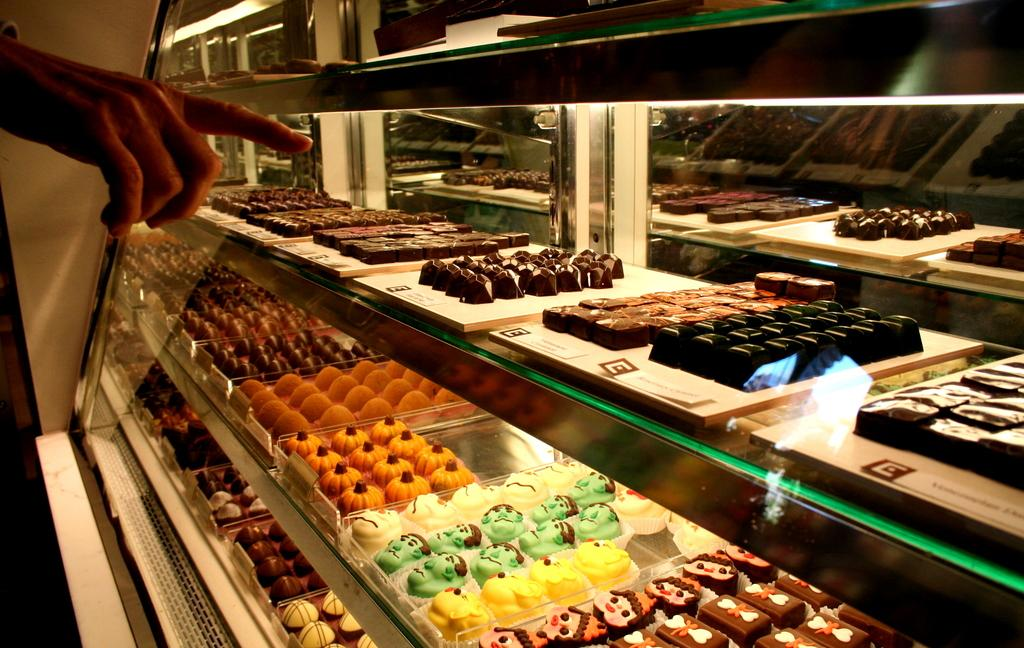What type of objects can be seen in the image? There are sweets in the image. What else is present in the image besides the sweets? There is a hand pointing at the sweets in the image. On which side of the image is the hand located? The hand is on the left side of the image. What type of map is visible on the right side of the image? There is no map present in the image; it only features sweets and a hand pointing at them. 